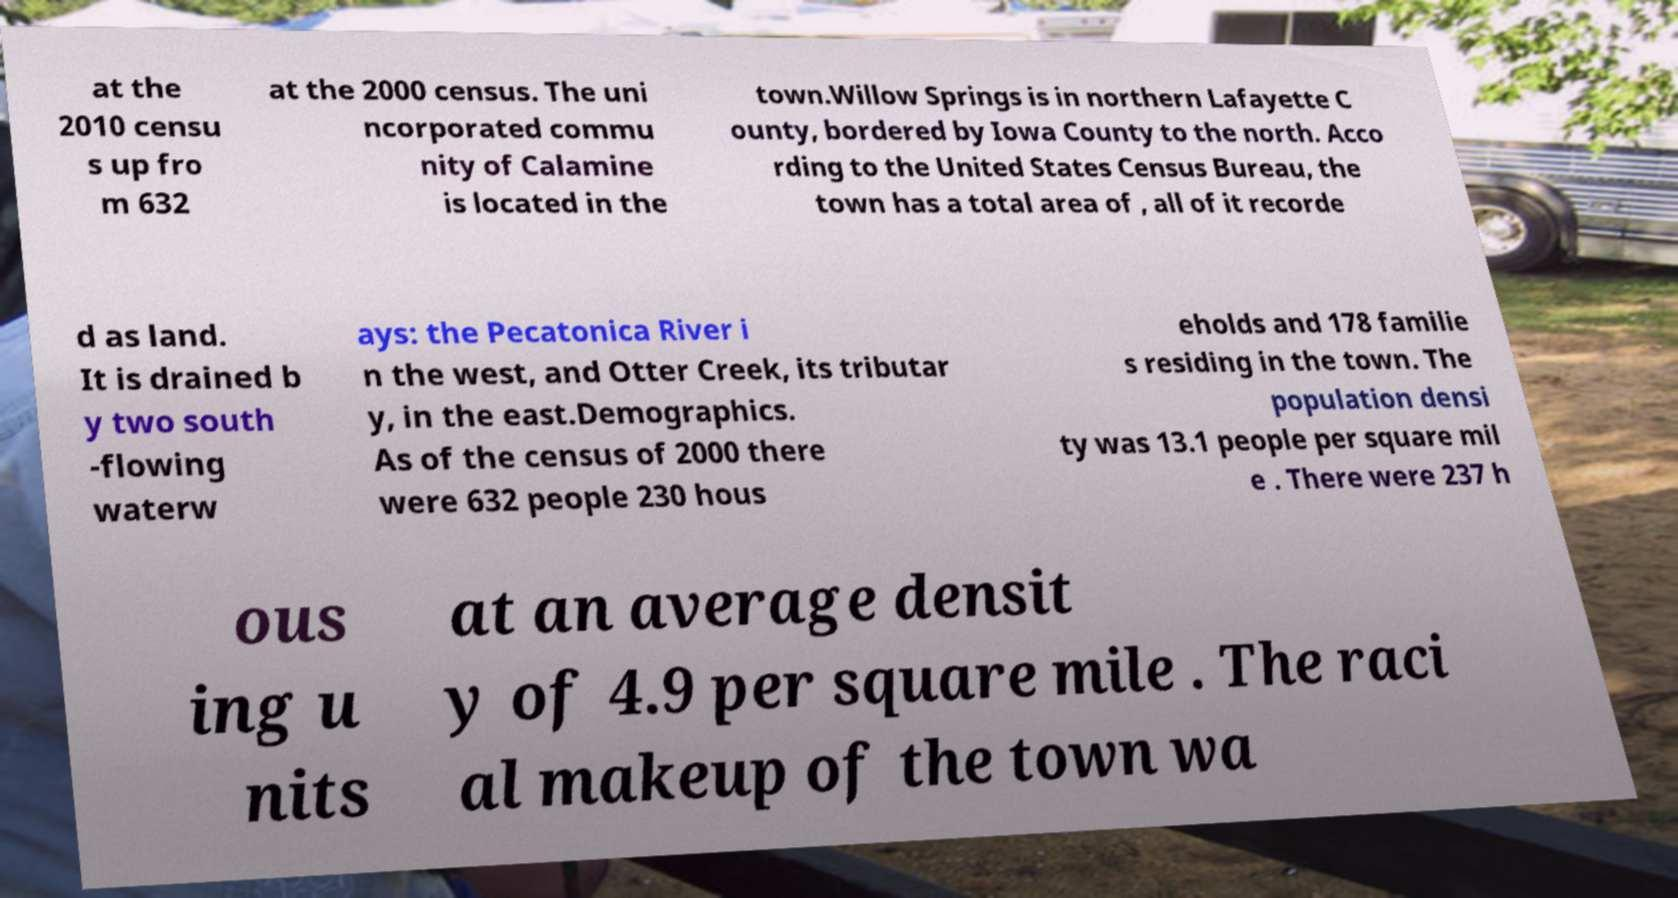Can you read and provide the text displayed in the image?This photo seems to have some interesting text. Can you extract and type it out for me? at the 2010 censu s up fro m 632 at the 2000 census. The uni ncorporated commu nity of Calamine is located in the town.Willow Springs is in northern Lafayette C ounty, bordered by Iowa County to the north. Acco rding to the United States Census Bureau, the town has a total area of , all of it recorde d as land. It is drained b y two south -flowing waterw ays: the Pecatonica River i n the west, and Otter Creek, its tributar y, in the east.Demographics. As of the census of 2000 there were 632 people 230 hous eholds and 178 familie s residing in the town. The population densi ty was 13.1 people per square mil e . There were 237 h ous ing u nits at an average densit y of 4.9 per square mile . The raci al makeup of the town wa 